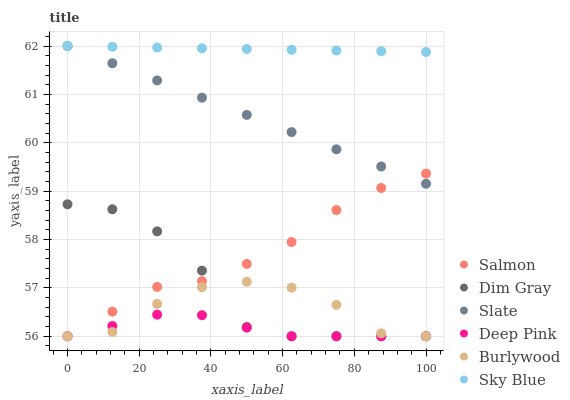Does Deep Pink have the minimum area under the curve?
Answer yes or no. Yes. Does Sky Blue have the maximum area under the curve?
Answer yes or no. Yes. Does Burlywood have the minimum area under the curve?
Answer yes or no. No. Does Burlywood have the maximum area under the curve?
Answer yes or no. No. Is Slate the smoothest?
Answer yes or no. Yes. Is Dim Gray the roughest?
Answer yes or no. Yes. Is Burlywood the smoothest?
Answer yes or no. No. Is Burlywood the roughest?
Answer yes or no. No. Does Dim Gray have the lowest value?
Answer yes or no. Yes. Does Slate have the lowest value?
Answer yes or no. No. Does Sky Blue have the highest value?
Answer yes or no. Yes. Does Burlywood have the highest value?
Answer yes or no. No. Is Burlywood less than Slate?
Answer yes or no. Yes. Is Sky Blue greater than Burlywood?
Answer yes or no. Yes. Does Slate intersect Sky Blue?
Answer yes or no. Yes. Is Slate less than Sky Blue?
Answer yes or no. No. Is Slate greater than Sky Blue?
Answer yes or no. No. Does Burlywood intersect Slate?
Answer yes or no. No. 